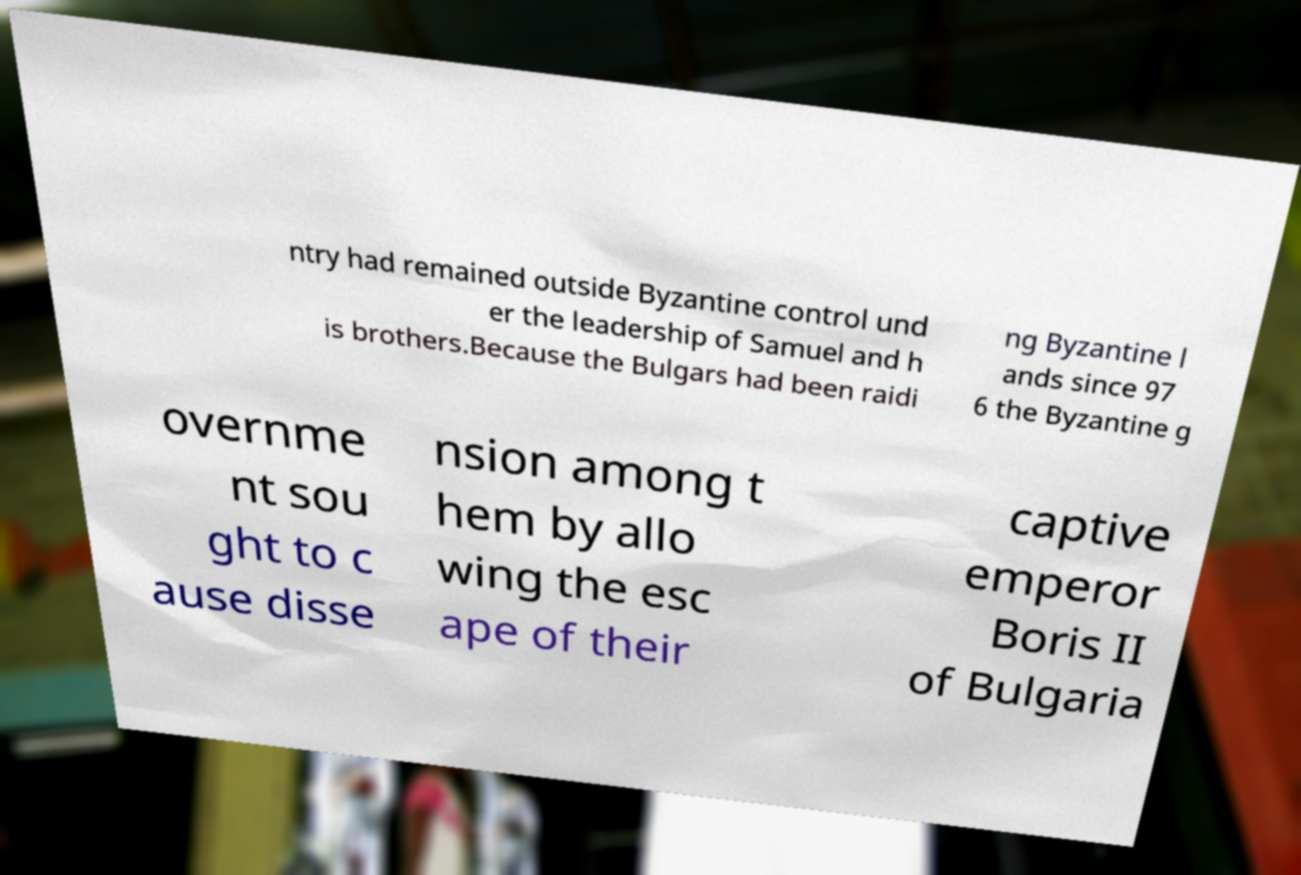There's text embedded in this image that I need extracted. Can you transcribe it verbatim? ntry had remained outside Byzantine control und er the leadership of Samuel and h is brothers.Because the Bulgars had been raidi ng Byzantine l ands since 97 6 the Byzantine g overnme nt sou ght to c ause disse nsion among t hem by allo wing the esc ape of their captive emperor Boris II of Bulgaria 